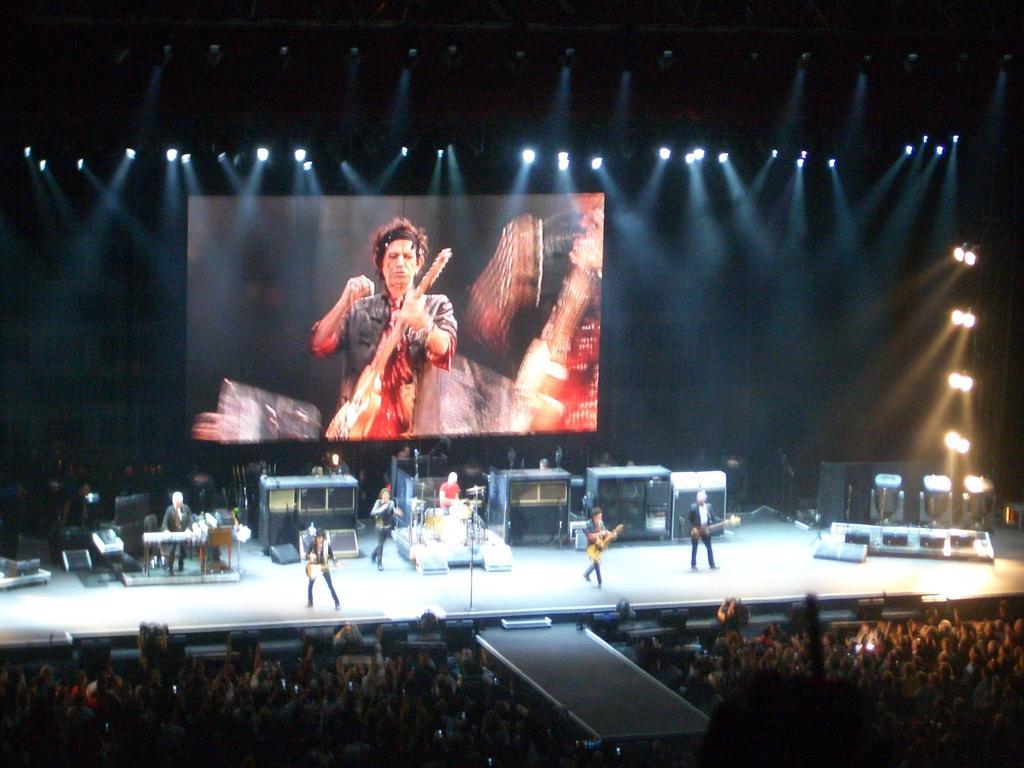Can you describe this image briefly? In the foreground of the picture there are audience. In the center of the picture it is stage, on the stage there are speakers, light and a band performing. At the top there are light and a led screen. On the stage there are people playing guitars, drums, keyboard and other musical instruments. 